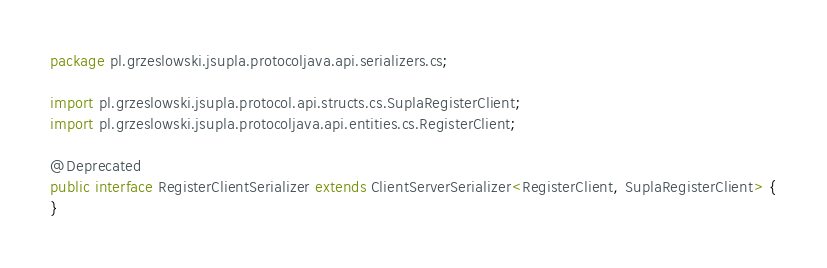Convert code to text. <code><loc_0><loc_0><loc_500><loc_500><_Java_>package pl.grzeslowski.jsupla.protocoljava.api.serializers.cs;

import pl.grzeslowski.jsupla.protocol.api.structs.cs.SuplaRegisterClient;
import pl.grzeslowski.jsupla.protocoljava.api.entities.cs.RegisterClient;

@Deprecated
public interface RegisterClientSerializer extends ClientServerSerializer<RegisterClient, SuplaRegisterClient> {
}
</code> 